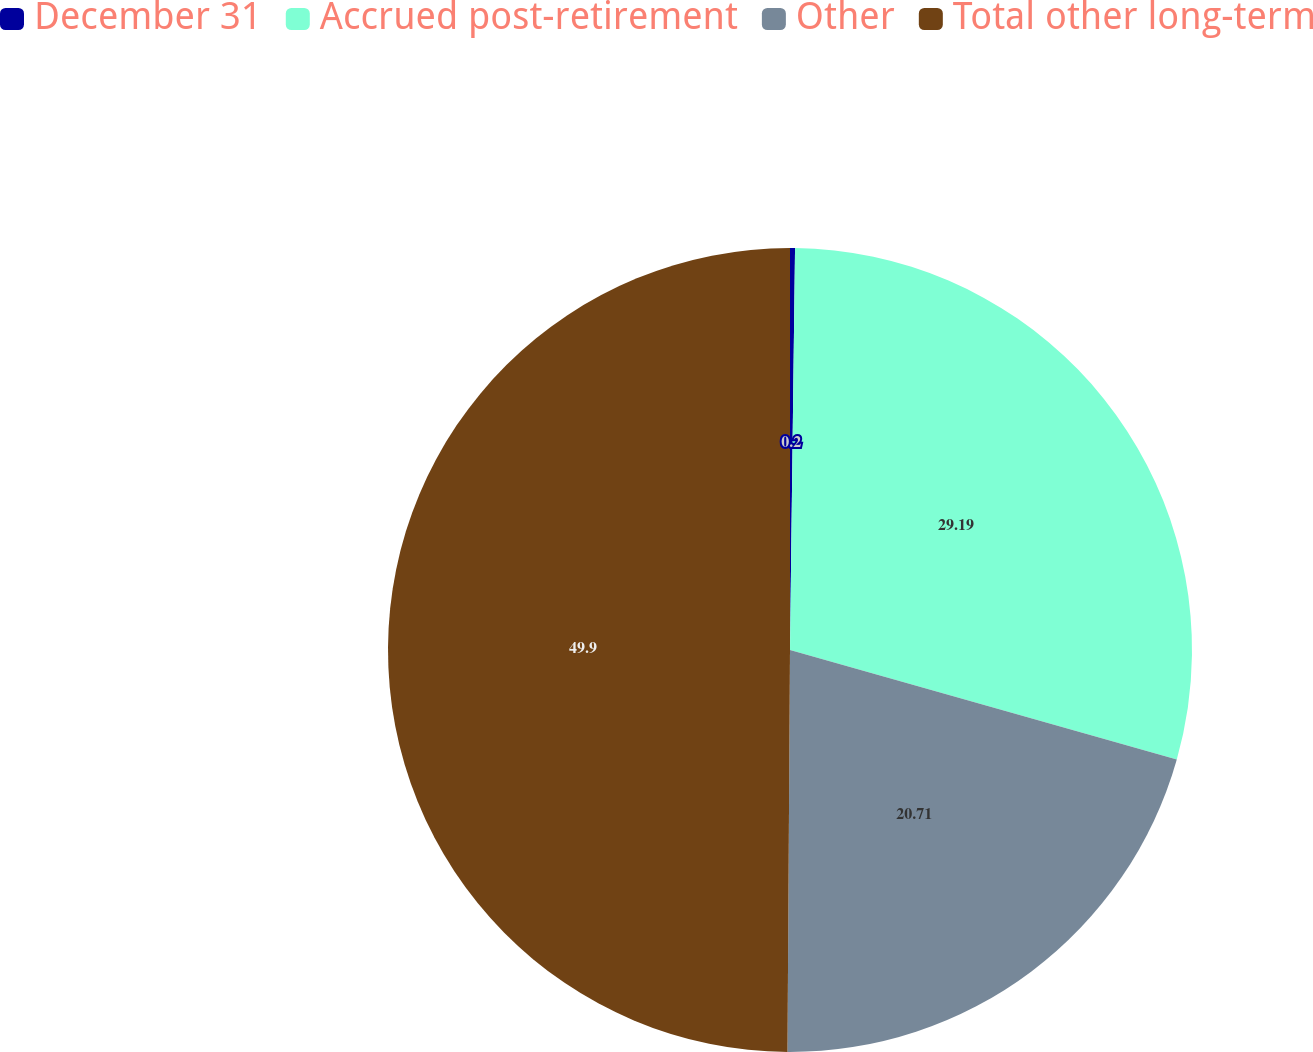Convert chart to OTSL. <chart><loc_0><loc_0><loc_500><loc_500><pie_chart><fcel>December 31<fcel>Accrued post-retirement<fcel>Other<fcel>Total other long-term<nl><fcel>0.2%<fcel>29.19%<fcel>20.71%<fcel>49.9%<nl></chart> 